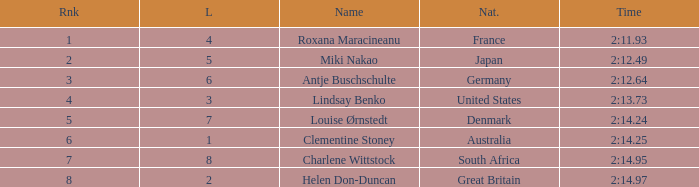What is the number of lane with a rank more than 2 for louise ørnstedt? 1.0. 